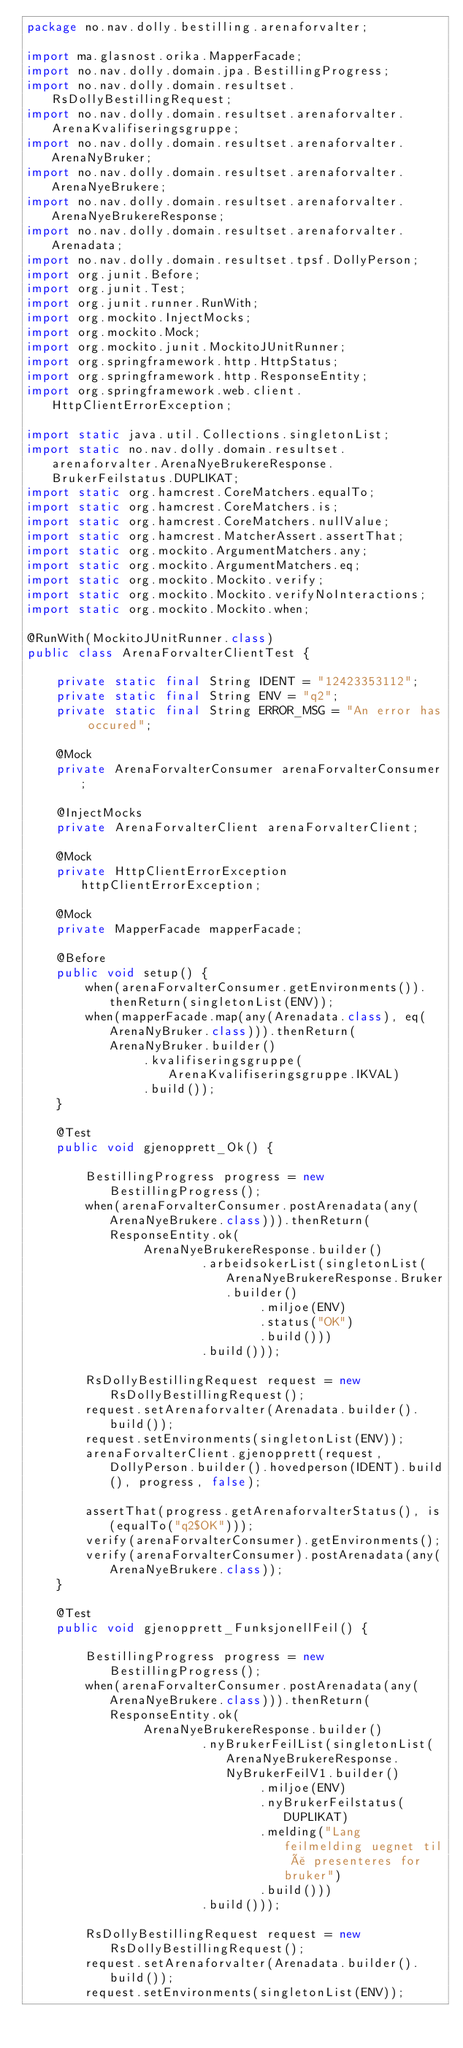<code> <loc_0><loc_0><loc_500><loc_500><_Java_>package no.nav.dolly.bestilling.arenaforvalter;

import ma.glasnost.orika.MapperFacade;
import no.nav.dolly.domain.jpa.BestillingProgress;
import no.nav.dolly.domain.resultset.RsDollyBestillingRequest;
import no.nav.dolly.domain.resultset.arenaforvalter.ArenaKvalifiseringsgruppe;
import no.nav.dolly.domain.resultset.arenaforvalter.ArenaNyBruker;
import no.nav.dolly.domain.resultset.arenaforvalter.ArenaNyeBrukere;
import no.nav.dolly.domain.resultset.arenaforvalter.ArenaNyeBrukereResponse;
import no.nav.dolly.domain.resultset.arenaforvalter.Arenadata;
import no.nav.dolly.domain.resultset.tpsf.DollyPerson;
import org.junit.Before;
import org.junit.Test;
import org.junit.runner.RunWith;
import org.mockito.InjectMocks;
import org.mockito.Mock;
import org.mockito.junit.MockitoJUnitRunner;
import org.springframework.http.HttpStatus;
import org.springframework.http.ResponseEntity;
import org.springframework.web.client.HttpClientErrorException;

import static java.util.Collections.singletonList;
import static no.nav.dolly.domain.resultset.arenaforvalter.ArenaNyeBrukereResponse.BrukerFeilstatus.DUPLIKAT;
import static org.hamcrest.CoreMatchers.equalTo;
import static org.hamcrest.CoreMatchers.is;
import static org.hamcrest.CoreMatchers.nullValue;
import static org.hamcrest.MatcherAssert.assertThat;
import static org.mockito.ArgumentMatchers.any;
import static org.mockito.ArgumentMatchers.eq;
import static org.mockito.Mockito.verify;
import static org.mockito.Mockito.verifyNoInteractions;
import static org.mockito.Mockito.when;

@RunWith(MockitoJUnitRunner.class)
public class ArenaForvalterClientTest {

    private static final String IDENT = "12423353112";
    private static final String ENV = "q2";
    private static final String ERROR_MSG = "An error has occured";

    @Mock
    private ArenaForvalterConsumer arenaForvalterConsumer;

    @InjectMocks
    private ArenaForvalterClient arenaForvalterClient;

    @Mock
    private HttpClientErrorException httpClientErrorException;

    @Mock
    private MapperFacade mapperFacade;

    @Before
    public void setup() {
        when(arenaForvalterConsumer.getEnvironments()).thenReturn(singletonList(ENV));
        when(mapperFacade.map(any(Arenadata.class), eq(ArenaNyBruker.class))).thenReturn(ArenaNyBruker.builder()
                .kvalifiseringsgruppe(ArenaKvalifiseringsgruppe.IKVAL)
                .build());
    }

    @Test
    public void gjenopprett_Ok() {

        BestillingProgress progress = new BestillingProgress();
        when(arenaForvalterConsumer.postArenadata(any(ArenaNyeBrukere.class))).thenReturn(ResponseEntity.ok(
                ArenaNyeBrukereResponse.builder()
                        .arbeidsokerList(singletonList(ArenaNyeBrukereResponse.Bruker.builder()
                                .miljoe(ENV)
                                .status("OK")
                                .build()))
                        .build()));

        RsDollyBestillingRequest request = new RsDollyBestillingRequest();
        request.setArenaforvalter(Arenadata.builder().build());
        request.setEnvironments(singletonList(ENV));
        arenaForvalterClient.gjenopprett(request, DollyPerson.builder().hovedperson(IDENT).build(), progress, false);

        assertThat(progress.getArenaforvalterStatus(), is(equalTo("q2$OK")));
        verify(arenaForvalterConsumer).getEnvironments();
        verify(arenaForvalterConsumer).postArenadata(any(ArenaNyeBrukere.class));
    }

    @Test
    public void gjenopprett_FunksjonellFeil() {

        BestillingProgress progress = new BestillingProgress();
        when(arenaForvalterConsumer.postArenadata(any(ArenaNyeBrukere.class))).thenReturn(ResponseEntity.ok(
                ArenaNyeBrukereResponse.builder()
                        .nyBrukerFeilList(singletonList(ArenaNyeBrukereResponse.NyBrukerFeilV1.builder()
                                .miljoe(ENV)
                                .nyBrukerFeilstatus(DUPLIKAT)
                                .melding("Lang feilmelding uegnet til å presenteres for bruker")
                                .build()))
                        .build()));

        RsDollyBestillingRequest request = new RsDollyBestillingRequest();
        request.setArenaforvalter(Arenadata.builder().build());
        request.setEnvironments(singletonList(ENV));</code> 